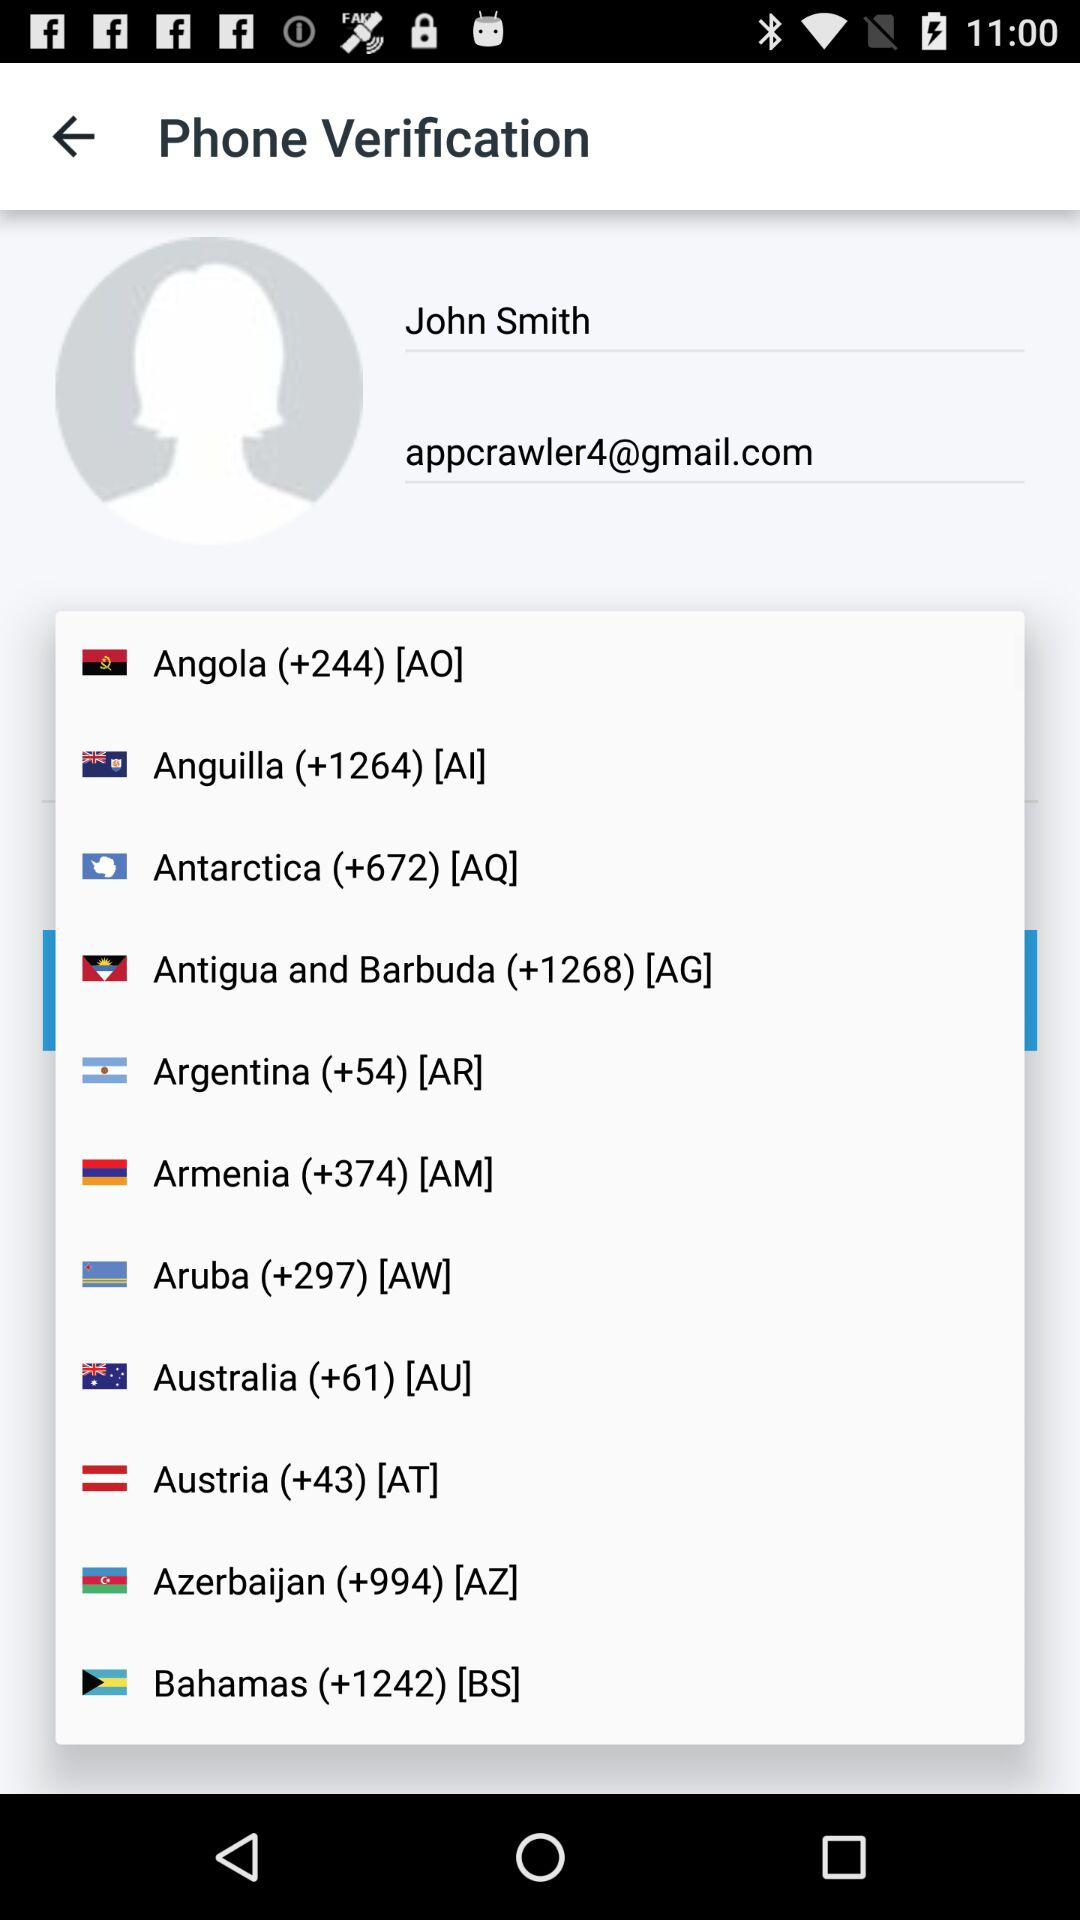What is the user name? The user name is John Smith. 